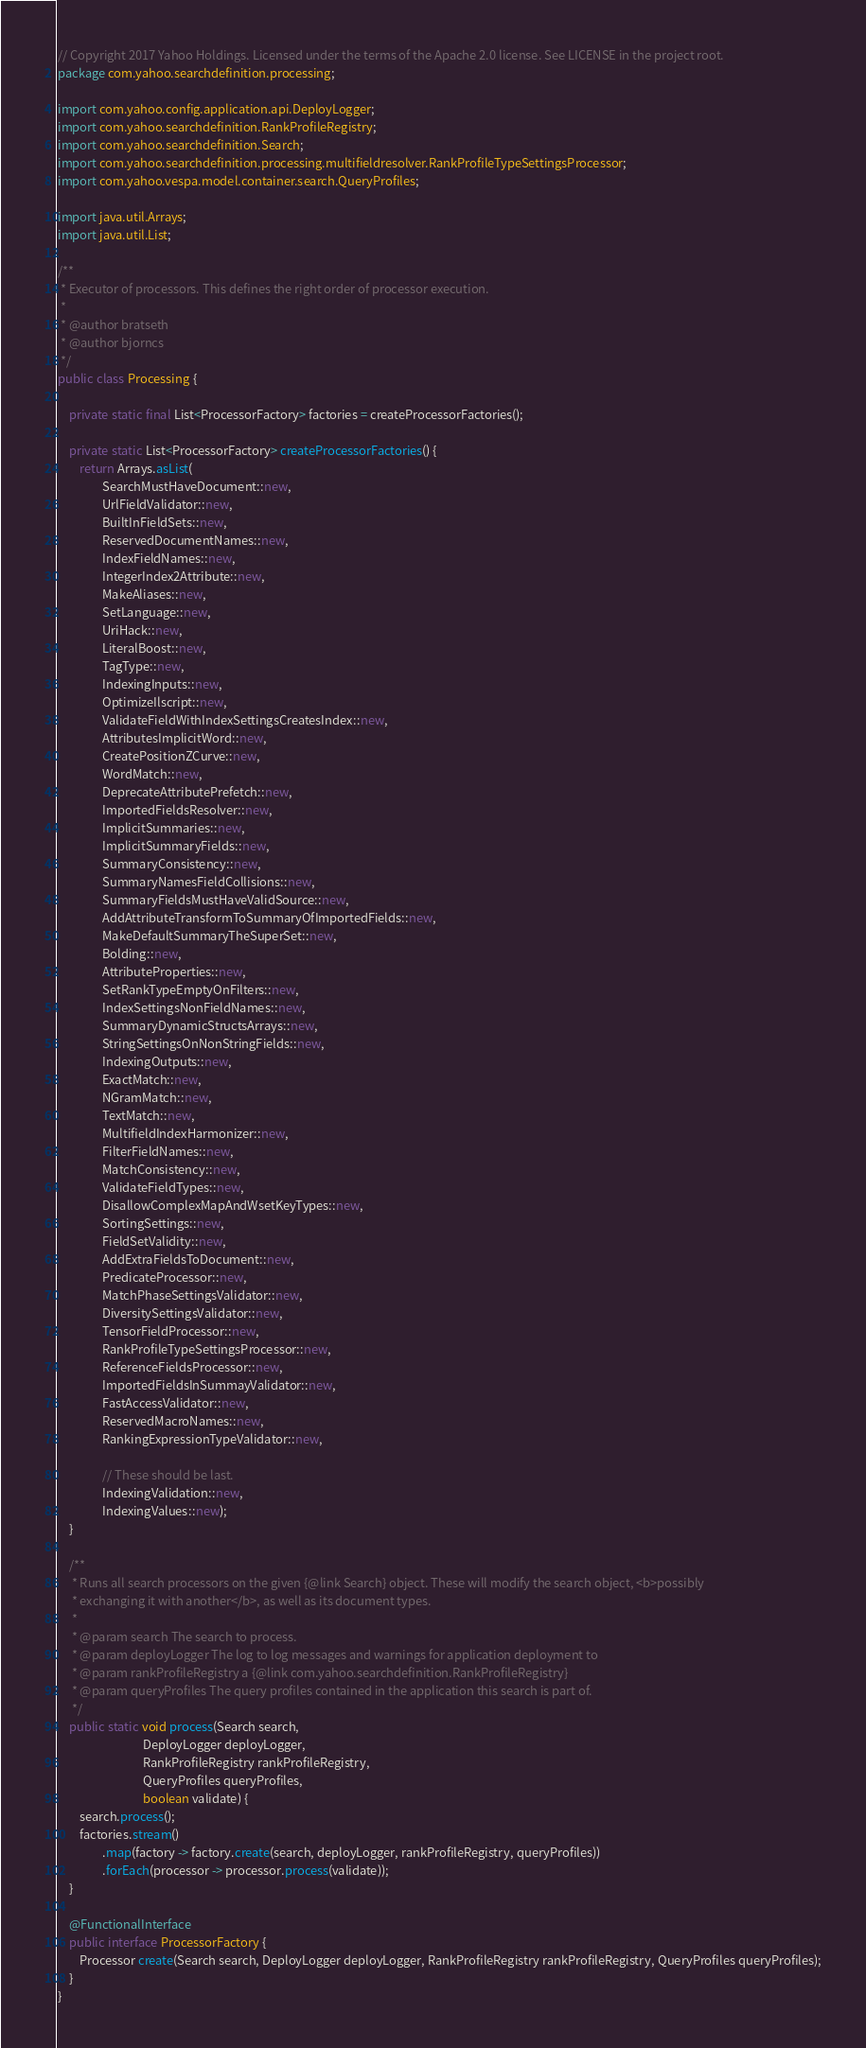<code> <loc_0><loc_0><loc_500><loc_500><_Java_>// Copyright 2017 Yahoo Holdings. Licensed under the terms of the Apache 2.0 license. See LICENSE in the project root.
package com.yahoo.searchdefinition.processing;

import com.yahoo.config.application.api.DeployLogger;
import com.yahoo.searchdefinition.RankProfileRegistry;
import com.yahoo.searchdefinition.Search;
import com.yahoo.searchdefinition.processing.multifieldresolver.RankProfileTypeSettingsProcessor;
import com.yahoo.vespa.model.container.search.QueryProfiles;

import java.util.Arrays;
import java.util.List;

/**
 * Executor of processors. This defines the right order of processor execution.
 *
 * @author bratseth
 * @author bjorncs
 */
public class Processing {

    private static final List<ProcessorFactory> factories = createProcessorFactories();

    private static List<ProcessorFactory> createProcessorFactories() {
        return Arrays.asList(
                SearchMustHaveDocument::new,
                UrlFieldValidator::new,
                BuiltInFieldSets::new,
                ReservedDocumentNames::new,
                IndexFieldNames::new,
                IntegerIndex2Attribute::new,
                MakeAliases::new,
                SetLanguage::new,
                UriHack::new,
                LiteralBoost::new,
                TagType::new,
                IndexingInputs::new,
                OptimizeIlscript::new,
                ValidateFieldWithIndexSettingsCreatesIndex::new,
                AttributesImplicitWord::new,
                CreatePositionZCurve::new,
                WordMatch::new,
                DeprecateAttributePrefetch::new,
                ImportedFieldsResolver::new,
                ImplicitSummaries::new,
                ImplicitSummaryFields::new,
                SummaryConsistency::new,
                SummaryNamesFieldCollisions::new,
                SummaryFieldsMustHaveValidSource::new,
                AddAttributeTransformToSummaryOfImportedFields::new,
                MakeDefaultSummaryTheSuperSet::new,
                Bolding::new,
                AttributeProperties::new,
                SetRankTypeEmptyOnFilters::new,
                IndexSettingsNonFieldNames::new,
                SummaryDynamicStructsArrays::new,
                StringSettingsOnNonStringFields::new,
                IndexingOutputs::new,
                ExactMatch::new,
                NGramMatch::new,
                TextMatch::new,
                MultifieldIndexHarmonizer::new,
                FilterFieldNames::new,
                MatchConsistency::new,
                ValidateFieldTypes::new,
                DisallowComplexMapAndWsetKeyTypes::new,
                SortingSettings::new,
                FieldSetValidity::new,
                AddExtraFieldsToDocument::new,
                PredicateProcessor::new,
                MatchPhaseSettingsValidator::new,
                DiversitySettingsValidator::new,
                TensorFieldProcessor::new,
                RankProfileTypeSettingsProcessor::new,
                ReferenceFieldsProcessor::new,
                ImportedFieldsInSummayValidator::new,
                FastAccessValidator::new,
                ReservedMacroNames::new,
                RankingExpressionTypeValidator::new,

                // These should be last.
                IndexingValidation::new,
                IndexingValues::new);
    }

    /**
     * Runs all search processors on the given {@link Search} object. These will modify the search object, <b>possibly
     * exchanging it with another</b>, as well as its document types.
     *
     * @param search The search to process.
     * @param deployLogger The log to log messages and warnings for application deployment to
     * @param rankProfileRegistry a {@link com.yahoo.searchdefinition.RankProfileRegistry}
     * @param queryProfiles The query profiles contained in the application this search is part of.
     */
    public static void process(Search search,
                               DeployLogger deployLogger,
                               RankProfileRegistry rankProfileRegistry,
                               QueryProfiles queryProfiles,
                               boolean validate) {
        search.process();
        factories.stream()
                .map(factory -> factory.create(search, deployLogger, rankProfileRegistry, queryProfiles))
                .forEach(processor -> processor.process(validate));
    }

    @FunctionalInterface
    public interface ProcessorFactory {
        Processor create(Search search, DeployLogger deployLogger, RankProfileRegistry rankProfileRegistry, QueryProfiles queryProfiles);
    }
}
</code> 